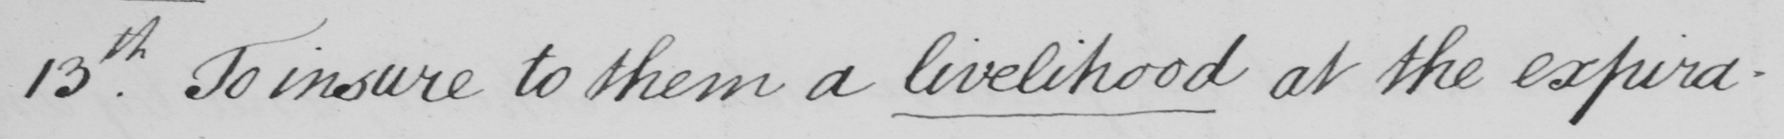Transcribe the text shown in this historical manuscript line. 13.th To insure to them a livelihood at the expira- 